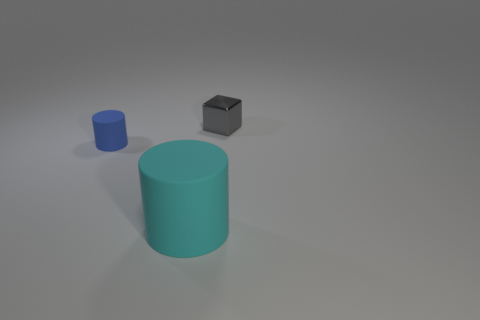Subtract all brown blocks. Subtract all purple cylinders. How many blocks are left? 1 Add 3 large yellow things. How many objects exist? 6 Subtract all cubes. How many objects are left? 2 Subtract all blue objects. Subtract all tiny green cubes. How many objects are left? 2 Add 1 small gray objects. How many small gray objects are left? 2 Add 3 tiny matte cylinders. How many tiny matte cylinders exist? 4 Subtract 0 purple cubes. How many objects are left? 3 